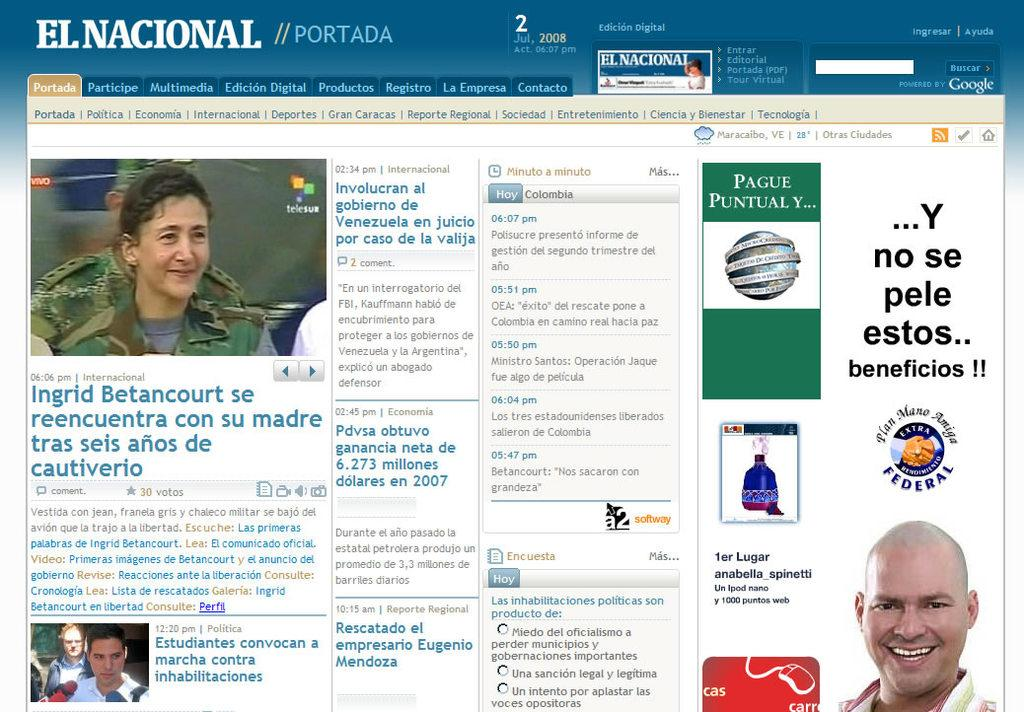What type of content is displayed on the web page? The web page contains pictures and letters. What can be used to find specific information on the web page? There is a search bar on the web page for searching. What are some interactive elements on the web page? There are options on the web page that can be clicked or selected. How are images displayed on the web page? Pictures are visible on the web page. What type of dress is the uncle wearing in the image? There is no uncle or dress present in the image, as it is a web page with pictures, letters, options, and a search bar. 